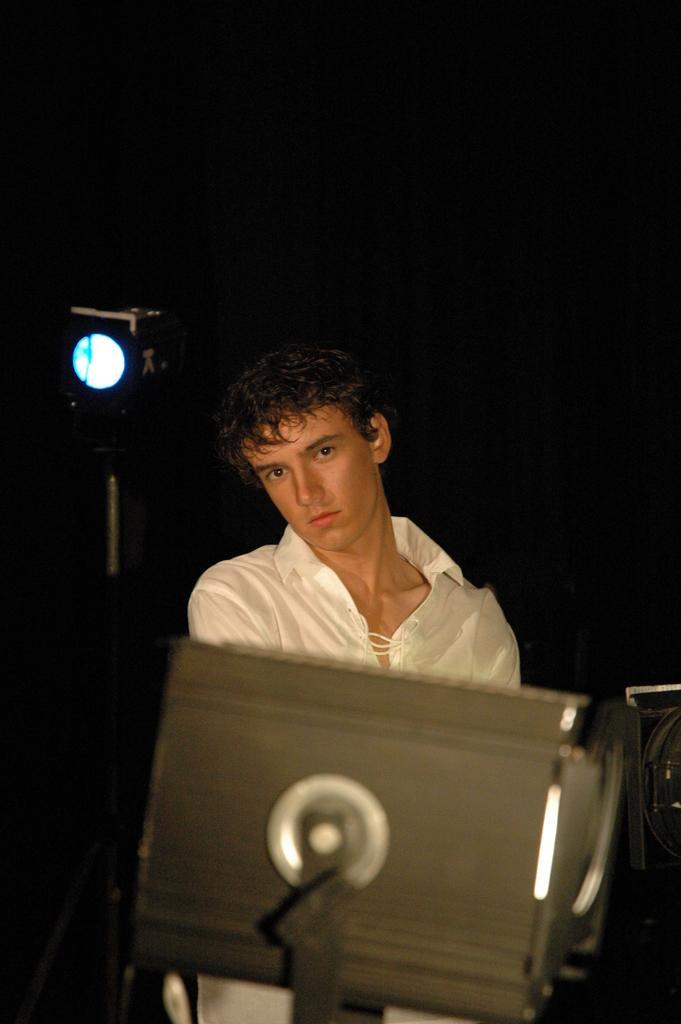Please provide a concise description of this image. In this image, in the middle, we can see metal instrument and a man wearing a white color shirt. On the left side, we can also see a light. In the background, we can see black color. 